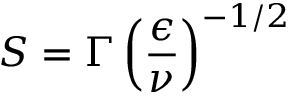Convert formula to latex. <formula><loc_0><loc_0><loc_500><loc_500>S = \Gamma \left ( \frac { \epsilon } { \nu } \right ) ^ { - 1 / 2 }</formula> 